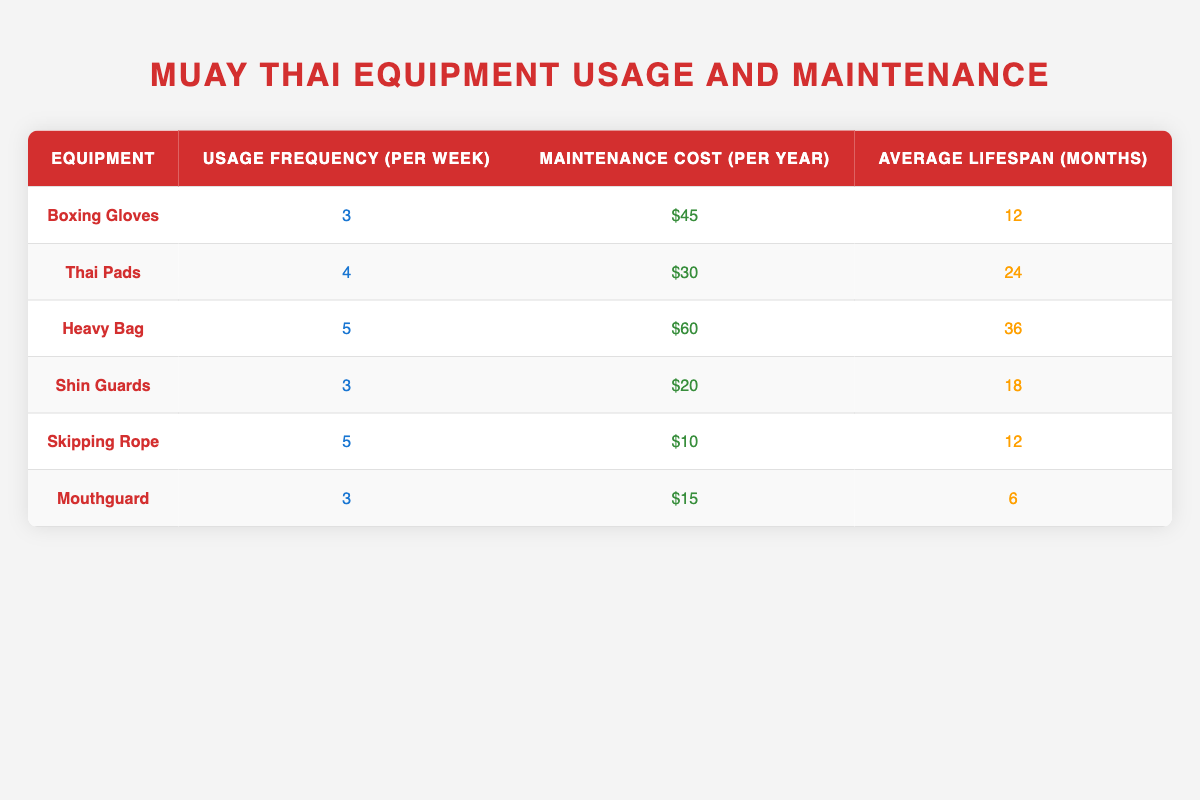What is the maintenance cost of Heavy Bag per year? The table lists the maintenance cost for each type of equipment. For the Heavy Bag, the corresponding value in the "Maintenance Cost (per year)" column is $60.
Answer: $60 How many times per week are Thai Pads used? The "Usage Frequency (per week)" column indicates how often each piece of equipment is used. For Thai Pads, it shows a frequency of 4 times per week.
Answer: 4 Which equipment has the longest average lifespan? By examining the "Average Lifespan (months)" column, we see that the Heavy Bag has the highest value at 36 months, indicating the longest lifespan among all listed equipment.
Answer: Heavy Bag What is the total maintenance cost for Skipping Rope and Mouthguard combined? To find the total maintenance cost for both the Skipping Rope and Mouthguard, we add their respective costs: $10 (Skipping Rope) + $15 (Mouthguard) = $25.
Answer: $25 Is the usage frequency of Shin Guards more than that of Thai Pads? The "Usage Frequency (per week)" for Shin Guards is 3, while for Thai Pads it is 4. Since 3 is not greater than 4, the answer is no.
Answer: No What is the average lifespan of all the equipment listed? We need to add the average lifespans together: 12 + 24 + 36 + 18 + 12 + 6 = 108 months. There are 6 equipment items, so we divide 108 by 6. Average lifespan = 108 / 6 = 18 months.
Answer: 18 months How often is the Mouthguard used compared to the Heavy Bag? The Mouthguard has a usage frequency of 3 times per week, while the Heavy Bag is used 5 times per week. Since 3 is less than 5, the answer is no.
Answer: No Which equipment has the highest frequency of usage? In the "Usage Frequency (per week)" column, the Heavy Bag has the highest frequency at 5 times per week, compared to other equipment.
Answer: Heavy Bag What is the difference in maintenance cost between Thai Pads and Shin Guards? To find the difference, we subtract the maintenance cost of Shin Guards from that of Thai Pads: $30 (Thai Pads) - $20 (Shin Guards) = $10.
Answer: $10 